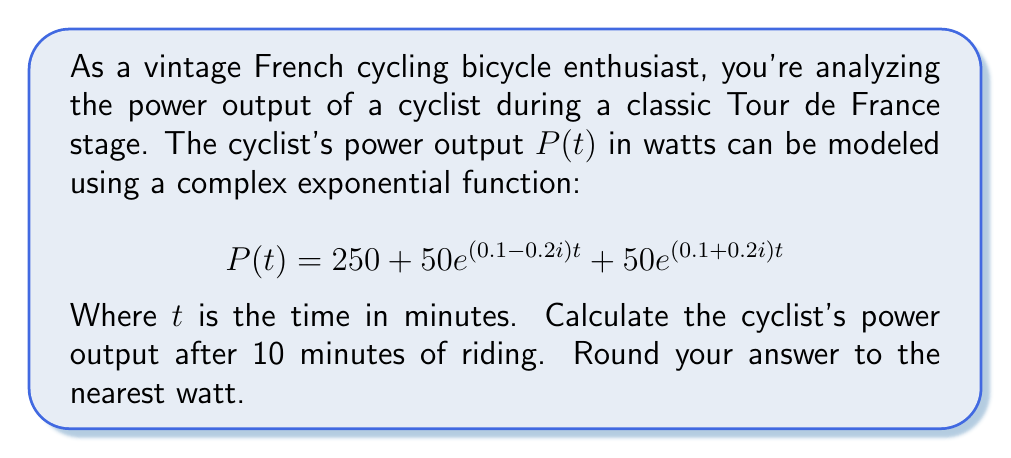What is the answer to this math problem? To solve this problem, we need to evaluate the given function at $t = 10$. Let's break it down step-by-step:

1) The function is given as:
   $$P(t) = 250 + 50e^{(0.1-0.2i)t} + 50e^{(0.1+0.2i)t}$$

2) We need to calculate $P(10)$. Let's evaluate each term separately:

   a) The first term is constant: 250

   b) For the second term: $50e^{(0.1-0.2i)10}$
      $$50e^{1-2i} = 50(e\cos 2 - ie\sin 2)$$

   c) For the third term: $50e^{(0.1+0.2i)10}$
      $$50e^{1+2i} = 50(e\cos 2 + ie\sin 2)$$

3) Adding these terms:
   $$P(10) = 250 + 50(e\cos 2 - ie\sin 2) + 50(e\cos 2 + ie\sin 2)$$

4) The imaginary parts cancel out:
   $$P(10) = 250 + 100e\cos 2$$

5) Calculate the value:
   $$P(10) = 250 + 100e\cos 2 \approx 250 + 100 \cdot 2.71828 \cdot (-0.41614) \approx 336.95$$

6) Rounding to the nearest watt:
   $$P(10) \approx 337\text{ watts}$$
Answer: 337 watts 